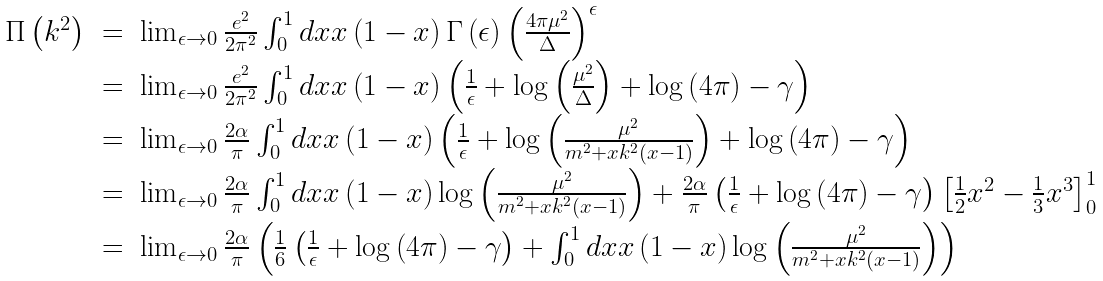Convert formula to latex. <formula><loc_0><loc_0><loc_500><loc_500>\begin{array} { r c l } \Pi \left ( k ^ { 2 } \right ) & = & \lim _ { \epsilon \rightarrow 0 } \frac { e ^ { 2 } } { 2 \pi ^ { 2 } } \int _ { 0 } ^ { 1 } d x x \left ( 1 - x \right ) \Gamma \left ( \epsilon \right ) \left ( \frac { 4 \pi \mu ^ { 2 } } { \Delta } \right ) ^ { \epsilon } \\ & = & \lim _ { \epsilon \rightarrow 0 } \frac { e ^ { 2 } } { 2 \pi ^ { 2 } } \int _ { 0 } ^ { 1 } d x x \left ( 1 - x \right ) \left ( \frac { 1 } { \epsilon } + \log \left ( \frac { \mu ^ { 2 } } { \Delta } \right ) + \log \left ( 4 \pi \right ) - \gamma \right ) \\ & = & \lim _ { \epsilon \rightarrow 0 } \frac { 2 \alpha } { \pi } \int _ { 0 } ^ { 1 } d x x \left ( 1 - x \right ) \left ( \frac { 1 } { \epsilon } + \log \left ( \frac { \mu ^ { 2 } } { m ^ { 2 } + x k ^ { 2 } \left ( x - 1 \right ) } \right ) + \log \left ( 4 \pi \right ) - \gamma \right ) \\ & = & \lim _ { \epsilon \rightarrow 0 } \frac { 2 \alpha } { \pi } \int _ { 0 } ^ { 1 } d x x \left ( 1 - x \right ) \log \left ( \frac { \mu ^ { 2 } } { m ^ { 2 } + x k ^ { 2 } \left ( x - 1 \right ) } \right ) + \frac { 2 \alpha } { \pi } \left ( \frac { 1 } { \epsilon } + \log \left ( 4 \pi \right ) - \gamma \right ) \left [ \frac { 1 } { 2 } x ^ { 2 } - \frac { 1 } { 3 } x ^ { 3 } \right ] _ { 0 } ^ { 1 } \\ & = & \lim _ { \epsilon \rightarrow 0 } \frac { 2 \alpha } { \pi } \left ( \frac { 1 } { 6 } \left ( \frac { 1 } { \epsilon } + \log \left ( 4 \pi \right ) - \gamma \right ) + \int _ { 0 } ^ { 1 } d x x \left ( 1 - x \right ) \log \left ( \frac { \mu ^ { 2 } } { m ^ { 2 } + x k ^ { 2 } \left ( x - 1 \right ) } \right ) \right ) \end{array}</formula> 